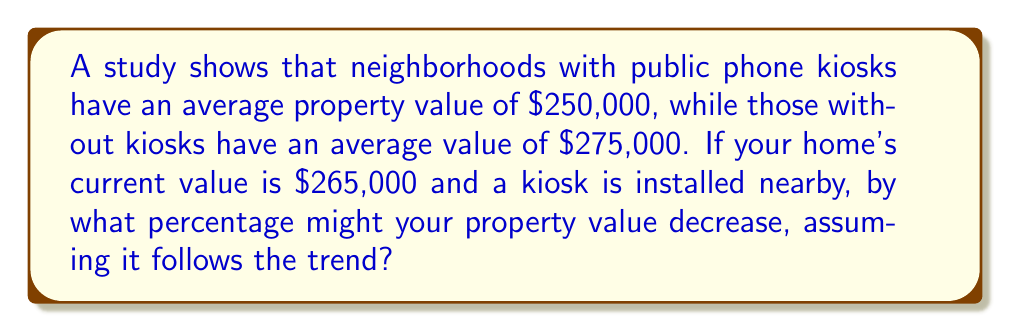Help me with this question. Let's approach this step-by-step:

1) First, let's calculate the difference in average property values:
   $275,000 - $250,000 = $25,000

2) This difference represents the potential decrease in value.

3) To calculate the percentage decrease, we use the formula:
   Percentage decrease = $\frac{\text{Decrease}}{\text{Original Value}} \times 100\%$

4) In this case:
   Percentage decrease = $\frac{25,000}{265,000} \times 100\%$

5) Let's solve this:
   $\frac{25,000}{265,000} = 0.09434$

6) Converting to a percentage:
   $0.09434 \times 100\% = 9.434\%$

7) Rounding to two decimal places:
   $9.43\%$

Therefore, based on the given trend, your property value might decrease by approximately 9.43% if a public phone kiosk is installed nearby.
Answer: $9.43\%$ 